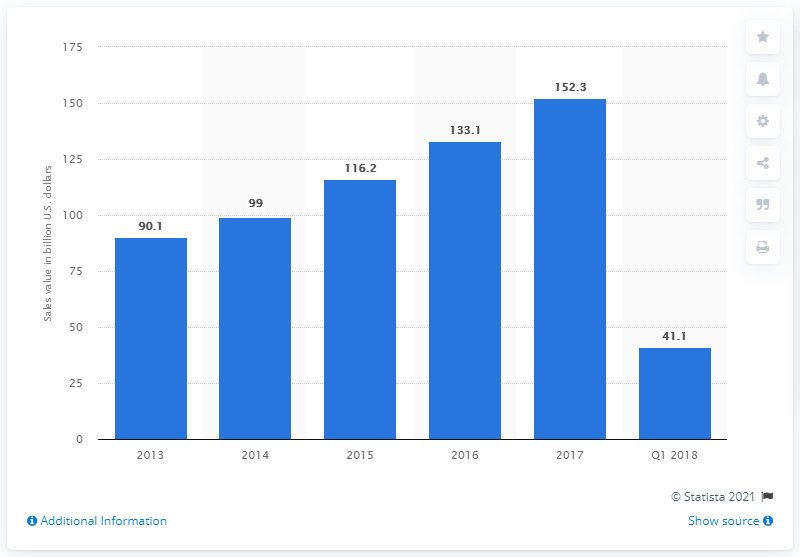Highlight a few significant elements in this photo. In the first quarter of 2018, the revenue from smartphone sales in China was 41.1 billion U.S. dollars. 